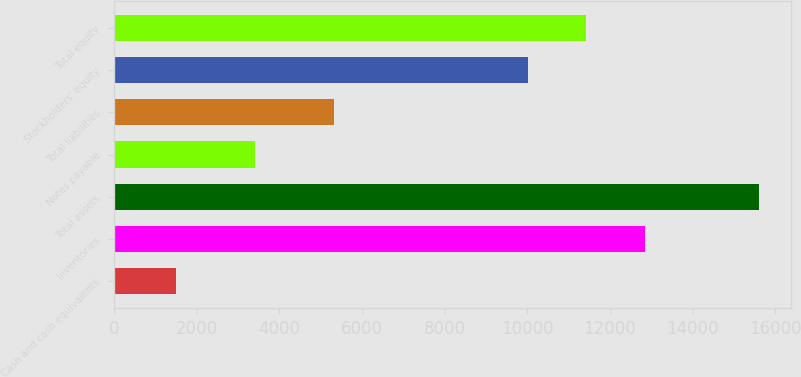Convert chart to OTSL. <chart><loc_0><loc_0><loc_500><loc_500><bar_chart><fcel>Cash and cash equivalents<fcel>Inventories<fcel>Total assets<fcel>Notes payable<fcel>Total liabilities<fcel>Stockholders' equity<fcel>Total equity<nl><fcel>1494.3<fcel>12843.4<fcel>15606.6<fcel>3399.4<fcel>5311.5<fcel>10020.9<fcel>11432.1<nl></chart> 